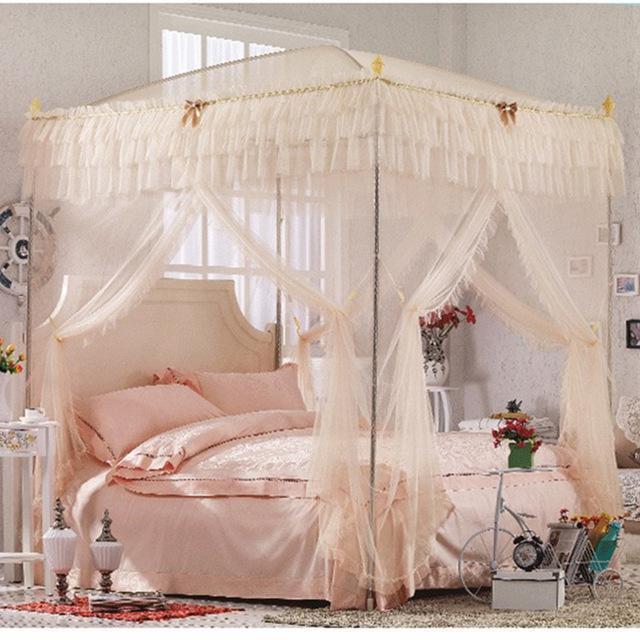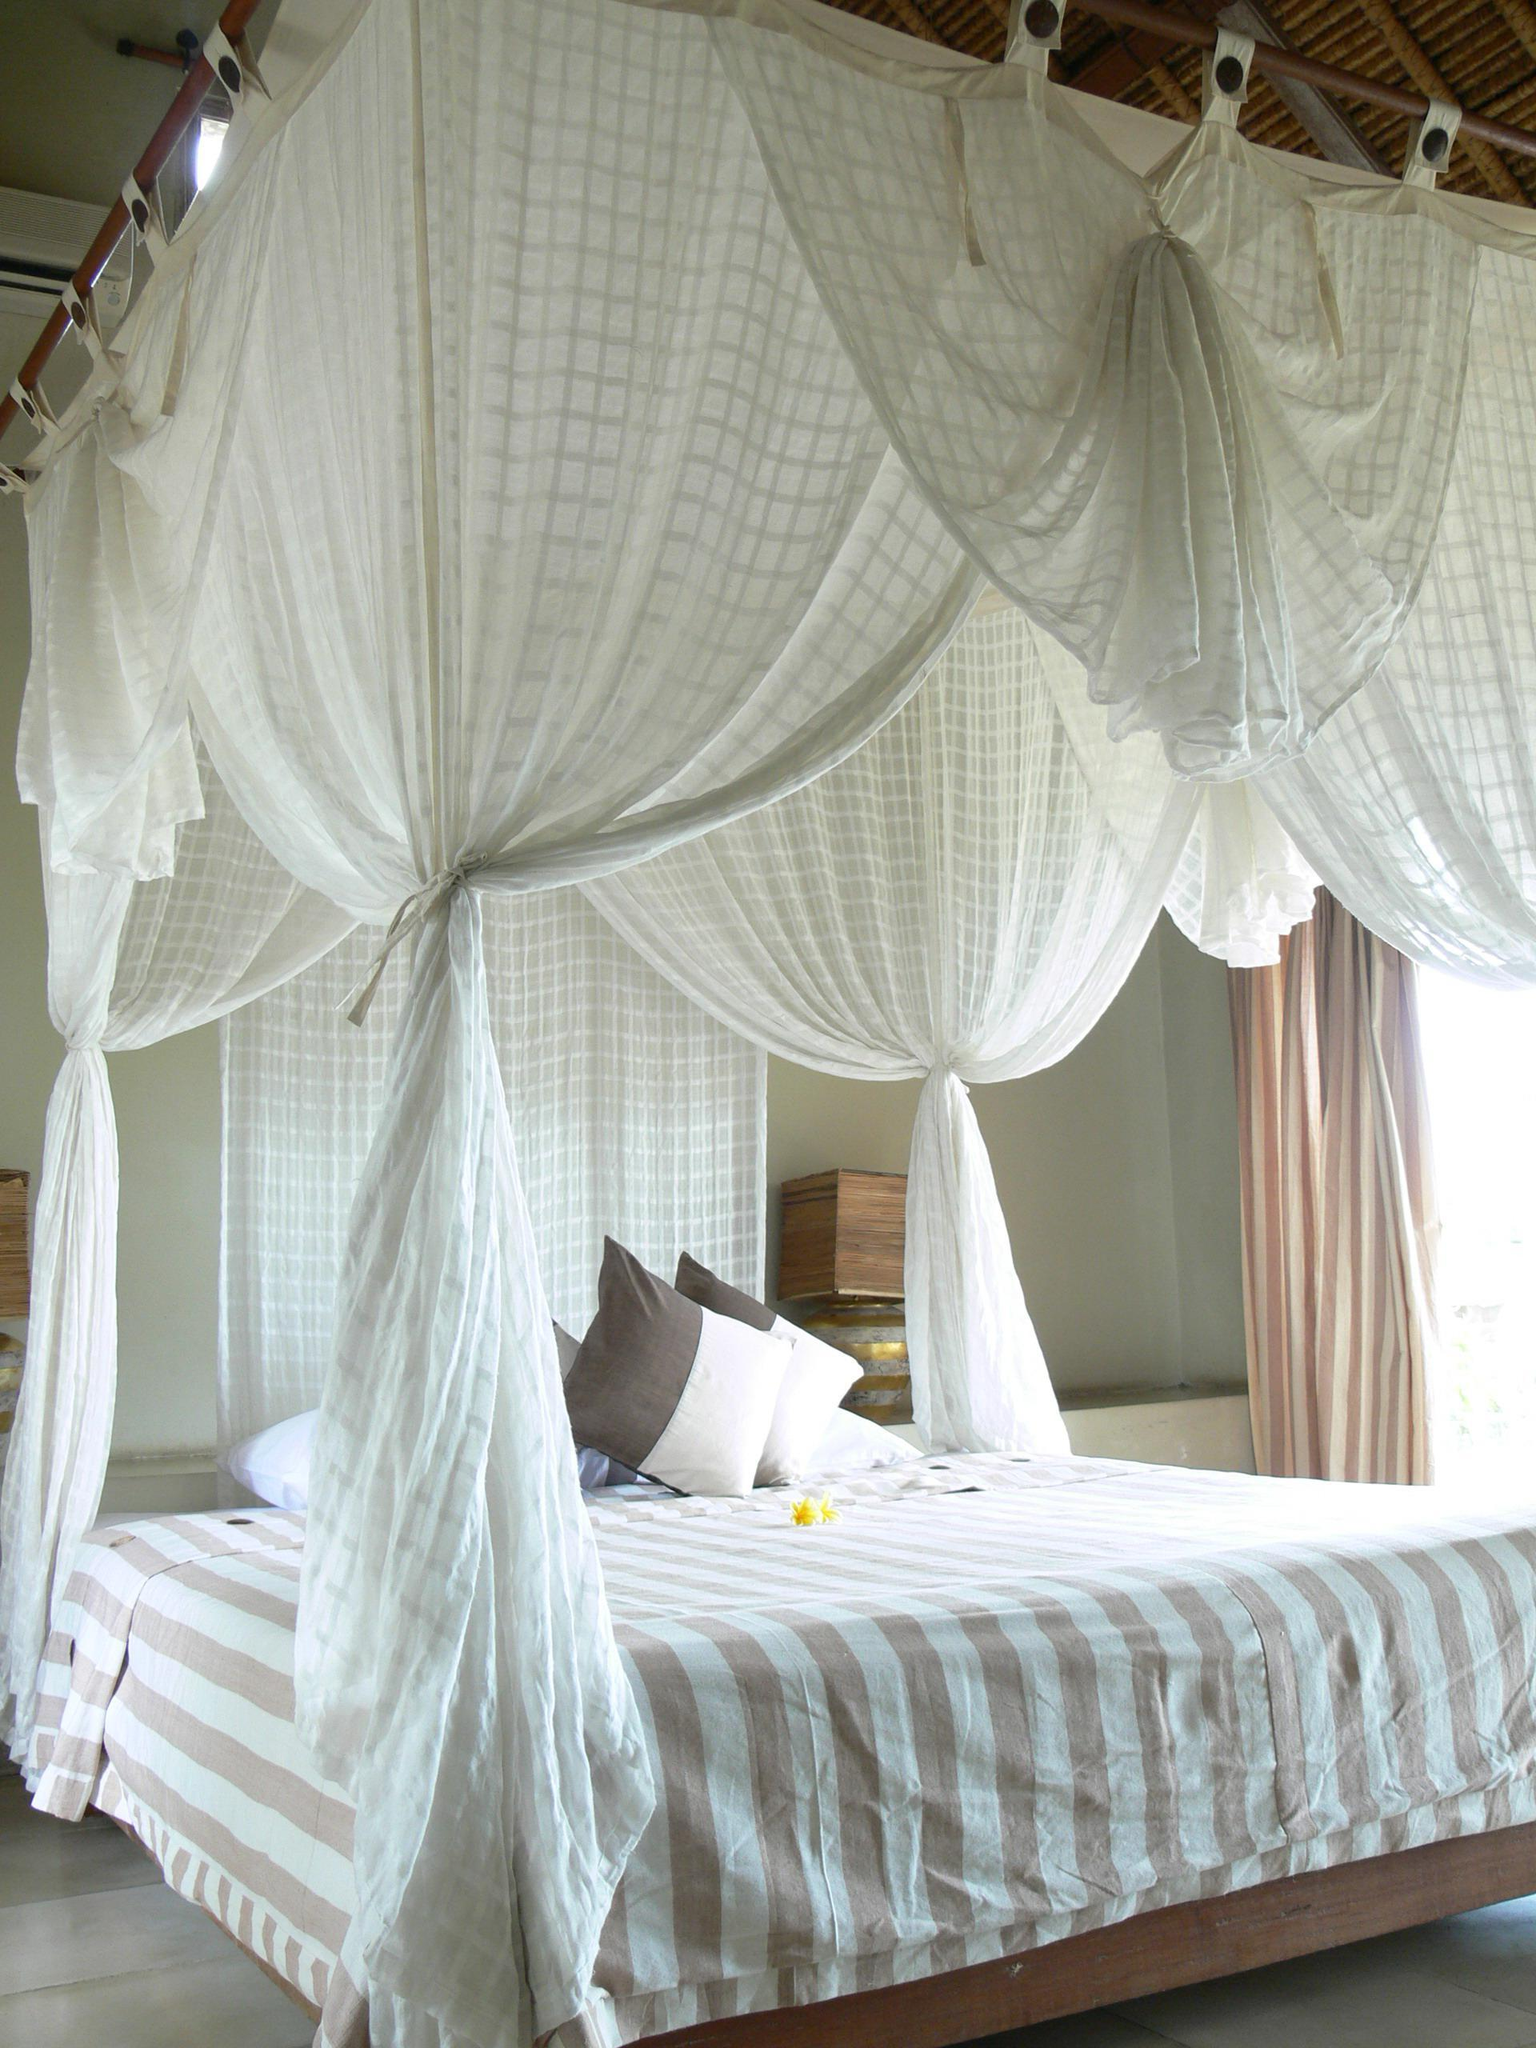The first image is the image on the left, the second image is the image on the right. Assess this claim about the two images: "Exactly one bed net is attached to the ceiling.". Correct or not? Answer yes or no. No. The first image is the image on the left, the second image is the image on the right. Analyze the images presented: Is the assertion "There are two white square canopies." valid? Answer yes or no. No. 